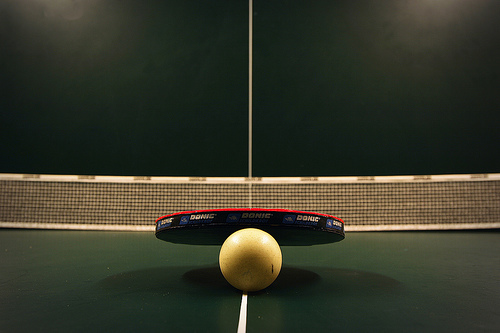<image>
Is there a ball in the grass? No. The ball is not contained within the grass. These objects have a different spatial relationship. 